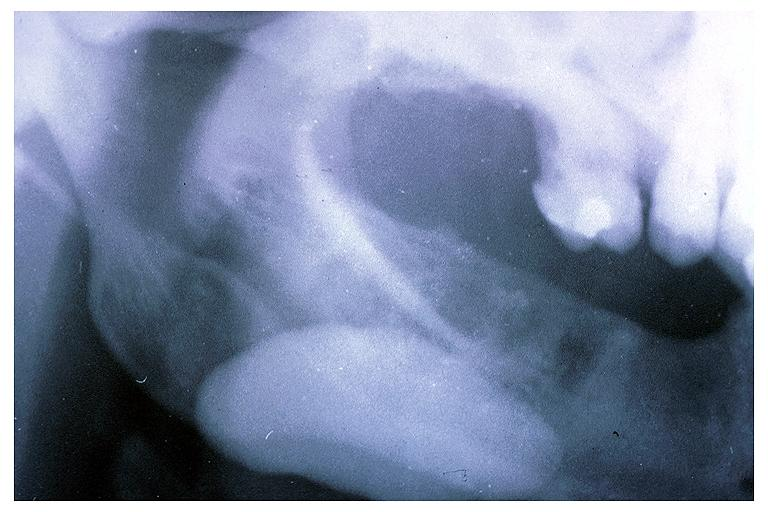s oral present?
Answer the question using a single word or phrase. Yes 